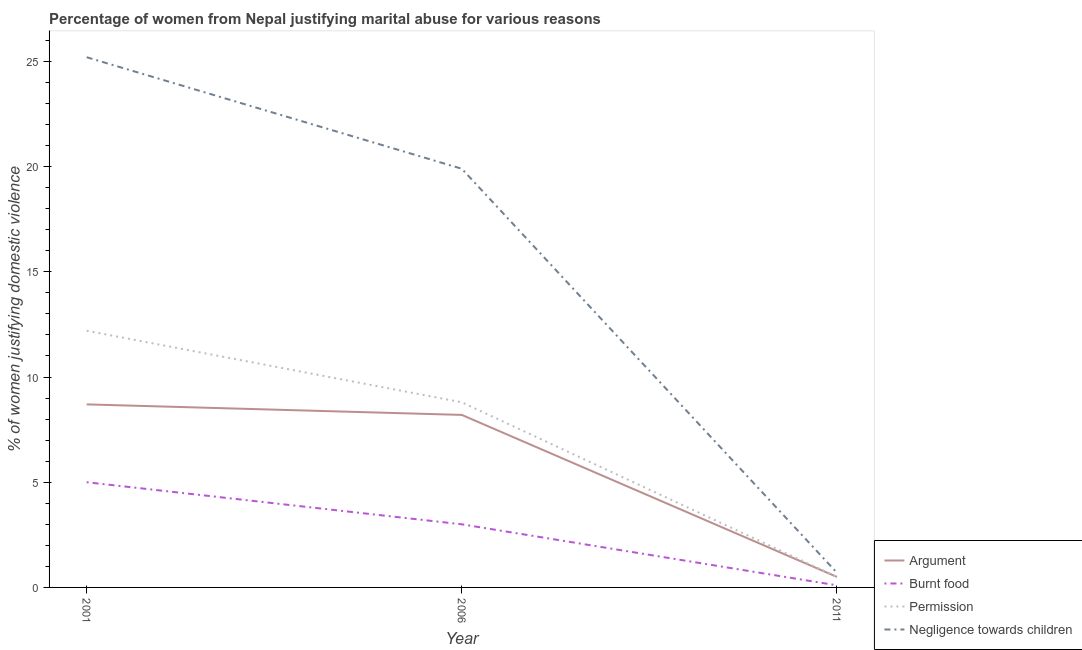How many different coloured lines are there?
Your answer should be compact. 4. Is the number of lines equal to the number of legend labels?
Keep it short and to the point. Yes. What is the percentage of women justifying abuse for burning food in 2006?
Offer a terse response. 3. Across all years, what is the maximum percentage of women justifying abuse in the case of an argument?
Make the answer very short. 8.7. In which year was the percentage of women justifying abuse for showing negligence towards children minimum?
Provide a succinct answer. 2011. What is the total percentage of women justifying abuse for showing negligence towards children in the graph?
Provide a succinct answer. 45.8. What is the difference between the percentage of women justifying abuse for showing negligence towards children in 2006 and that in 2011?
Offer a terse response. 19.2. What is the difference between the percentage of women justifying abuse in the case of an argument in 2011 and the percentage of women justifying abuse for showing negligence towards children in 2001?
Your answer should be compact. -24.7. What is the average percentage of women justifying abuse in the case of an argument per year?
Keep it short and to the point. 5.8. In the year 2001, what is the difference between the percentage of women justifying abuse for showing negligence towards children and percentage of women justifying abuse for burning food?
Offer a terse response. 20.2. What is the difference between the highest and the second highest percentage of women justifying abuse for going without permission?
Provide a succinct answer. 3.4. Is the sum of the percentage of women justifying abuse in the case of an argument in 2001 and 2011 greater than the maximum percentage of women justifying abuse for burning food across all years?
Keep it short and to the point. Yes. Is it the case that in every year, the sum of the percentage of women justifying abuse in the case of an argument and percentage of women justifying abuse for burning food is greater than the percentage of women justifying abuse for going without permission?
Your answer should be very brief. Yes. Is the percentage of women justifying abuse for showing negligence towards children strictly greater than the percentage of women justifying abuse for going without permission over the years?
Provide a succinct answer. Yes. Is the percentage of women justifying abuse for burning food strictly less than the percentage of women justifying abuse in the case of an argument over the years?
Make the answer very short. Yes. How many lines are there?
Ensure brevity in your answer.  4. How many years are there in the graph?
Provide a short and direct response. 3. What is the difference between two consecutive major ticks on the Y-axis?
Provide a succinct answer. 5. Does the graph contain any zero values?
Offer a very short reply. No. What is the title of the graph?
Your answer should be compact. Percentage of women from Nepal justifying marital abuse for various reasons. Does "Ease of arranging shipments" appear as one of the legend labels in the graph?
Your response must be concise. No. What is the label or title of the Y-axis?
Provide a short and direct response. % of women justifying domestic violence. What is the % of women justifying domestic violence of Argument in 2001?
Offer a very short reply. 8.7. What is the % of women justifying domestic violence in Burnt food in 2001?
Keep it short and to the point. 5. What is the % of women justifying domestic violence of Permission in 2001?
Your answer should be compact. 12.2. What is the % of women justifying domestic violence of Negligence towards children in 2001?
Offer a terse response. 25.2. What is the % of women justifying domestic violence in Argument in 2006?
Your answer should be very brief. 8.2. What is the % of women justifying domestic violence of Permission in 2006?
Give a very brief answer. 8.8. What is the % of women justifying domestic violence of Argument in 2011?
Make the answer very short. 0.5. Across all years, what is the maximum % of women justifying domestic violence in Argument?
Offer a very short reply. 8.7. Across all years, what is the maximum % of women justifying domestic violence in Burnt food?
Your response must be concise. 5. Across all years, what is the maximum % of women justifying domestic violence in Permission?
Ensure brevity in your answer.  12.2. Across all years, what is the maximum % of women justifying domestic violence of Negligence towards children?
Offer a very short reply. 25.2. Across all years, what is the minimum % of women justifying domestic violence in Burnt food?
Provide a short and direct response. 0.1. Across all years, what is the minimum % of women justifying domestic violence in Permission?
Give a very brief answer. 0.5. What is the total % of women justifying domestic violence of Argument in the graph?
Your answer should be very brief. 17.4. What is the total % of women justifying domestic violence of Burnt food in the graph?
Ensure brevity in your answer.  8.1. What is the total % of women justifying domestic violence of Negligence towards children in the graph?
Your answer should be very brief. 45.8. What is the difference between the % of women justifying domestic violence of Burnt food in 2001 and that in 2006?
Your answer should be compact. 2. What is the difference between the % of women justifying domestic violence in Permission in 2001 and that in 2006?
Provide a short and direct response. 3.4. What is the difference between the % of women justifying domestic violence of Burnt food in 2001 and that in 2011?
Offer a very short reply. 4.9. What is the difference between the % of women justifying domestic violence in Permission in 2001 and that in 2011?
Provide a succinct answer. 11.7. What is the difference between the % of women justifying domestic violence of Negligence towards children in 2001 and that in 2011?
Provide a short and direct response. 24.5. What is the difference between the % of women justifying domestic violence in Argument in 2006 and that in 2011?
Provide a short and direct response. 7.7. What is the difference between the % of women justifying domestic violence in Permission in 2006 and that in 2011?
Give a very brief answer. 8.3. What is the difference between the % of women justifying domestic violence of Argument in 2001 and the % of women justifying domestic violence of Permission in 2006?
Your answer should be very brief. -0.1. What is the difference between the % of women justifying domestic violence of Burnt food in 2001 and the % of women justifying domestic violence of Negligence towards children in 2006?
Offer a very short reply. -14.9. What is the difference between the % of women justifying domestic violence of Argument in 2001 and the % of women justifying domestic violence of Burnt food in 2011?
Provide a succinct answer. 8.6. What is the difference between the % of women justifying domestic violence of Permission in 2001 and the % of women justifying domestic violence of Negligence towards children in 2011?
Keep it short and to the point. 11.5. What is the difference between the % of women justifying domestic violence in Argument in 2006 and the % of women justifying domestic violence in Negligence towards children in 2011?
Provide a succinct answer. 7.5. What is the difference between the % of women justifying domestic violence in Burnt food in 2006 and the % of women justifying domestic violence in Negligence towards children in 2011?
Give a very brief answer. 2.3. What is the difference between the % of women justifying domestic violence of Permission in 2006 and the % of women justifying domestic violence of Negligence towards children in 2011?
Provide a short and direct response. 8.1. What is the average % of women justifying domestic violence of Burnt food per year?
Offer a terse response. 2.7. What is the average % of women justifying domestic violence in Permission per year?
Your answer should be compact. 7.17. What is the average % of women justifying domestic violence of Negligence towards children per year?
Offer a terse response. 15.27. In the year 2001, what is the difference between the % of women justifying domestic violence in Argument and % of women justifying domestic violence in Burnt food?
Provide a succinct answer. 3.7. In the year 2001, what is the difference between the % of women justifying domestic violence in Argument and % of women justifying domestic violence in Permission?
Keep it short and to the point. -3.5. In the year 2001, what is the difference between the % of women justifying domestic violence of Argument and % of women justifying domestic violence of Negligence towards children?
Ensure brevity in your answer.  -16.5. In the year 2001, what is the difference between the % of women justifying domestic violence in Burnt food and % of women justifying domestic violence in Permission?
Your answer should be compact. -7.2. In the year 2001, what is the difference between the % of women justifying domestic violence of Burnt food and % of women justifying domestic violence of Negligence towards children?
Provide a short and direct response. -20.2. In the year 2006, what is the difference between the % of women justifying domestic violence in Argument and % of women justifying domestic violence in Burnt food?
Provide a succinct answer. 5.2. In the year 2006, what is the difference between the % of women justifying domestic violence in Burnt food and % of women justifying domestic violence in Permission?
Offer a terse response. -5.8. In the year 2006, what is the difference between the % of women justifying domestic violence in Burnt food and % of women justifying domestic violence in Negligence towards children?
Your answer should be compact. -16.9. In the year 2011, what is the difference between the % of women justifying domestic violence of Argument and % of women justifying domestic violence of Burnt food?
Provide a short and direct response. 0.4. In the year 2011, what is the difference between the % of women justifying domestic violence of Argument and % of women justifying domestic violence of Permission?
Offer a terse response. 0. In the year 2011, what is the difference between the % of women justifying domestic violence of Burnt food and % of women justifying domestic violence of Permission?
Offer a very short reply. -0.4. In the year 2011, what is the difference between the % of women justifying domestic violence of Burnt food and % of women justifying domestic violence of Negligence towards children?
Your answer should be compact. -0.6. What is the ratio of the % of women justifying domestic violence in Argument in 2001 to that in 2006?
Your response must be concise. 1.06. What is the ratio of the % of women justifying domestic violence of Burnt food in 2001 to that in 2006?
Offer a terse response. 1.67. What is the ratio of the % of women justifying domestic violence in Permission in 2001 to that in 2006?
Provide a succinct answer. 1.39. What is the ratio of the % of women justifying domestic violence of Negligence towards children in 2001 to that in 2006?
Provide a succinct answer. 1.27. What is the ratio of the % of women justifying domestic violence of Argument in 2001 to that in 2011?
Give a very brief answer. 17.4. What is the ratio of the % of women justifying domestic violence in Burnt food in 2001 to that in 2011?
Make the answer very short. 50. What is the ratio of the % of women justifying domestic violence in Permission in 2001 to that in 2011?
Ensure brevity in your answer.  24.4. What is the ratio of the % of women justifying domestic violence in Argument in 2006 to that in 2011?
Your answer should be very brief. 16.4. What is the ratio of the % of women justifying domestic violence in Negligence towards children in 2006 to that in 2011?
Make the answer very short. 28.43. What is the difference between the highest and the second highest % of women justifying domestic violence of Argument?
Your response must be concise. 0.5. What is the difference between the highest and the second highest % of women justifying domestic violence of Burnt food?
Give a very brief answer. 2. What is the difference between the highest and the lowest % of women justifying domestic violence in Argument?
Your answer should be very brief. 8.2. 